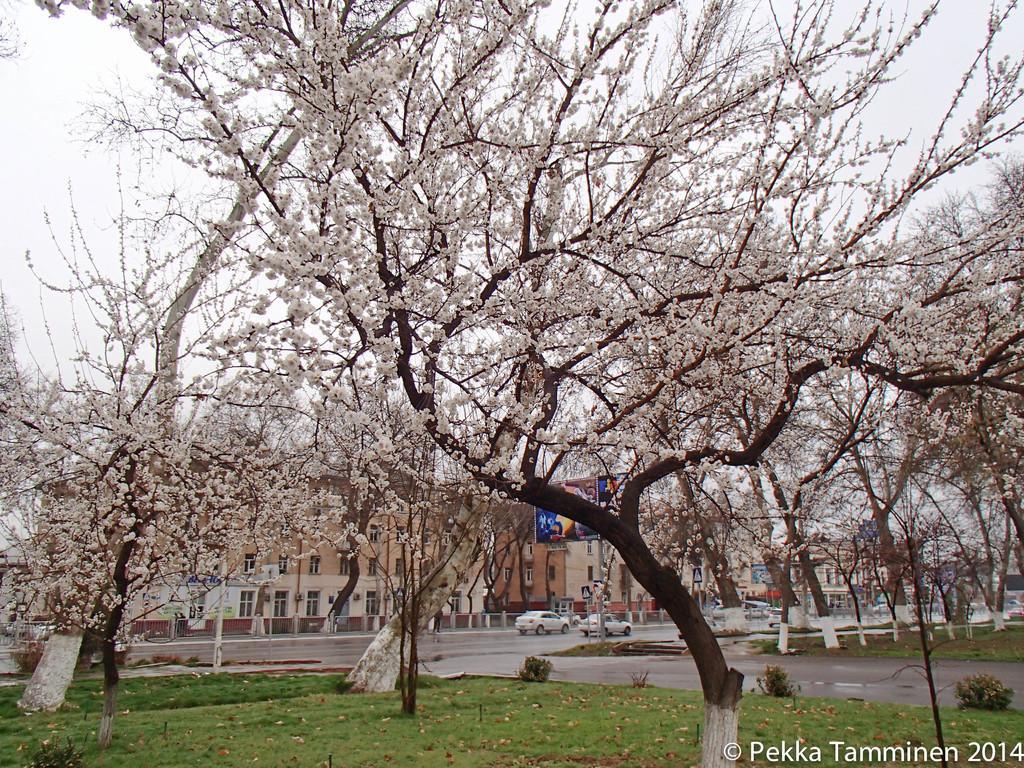Can you describe this image briefly? In the foreground of the picture I can see the trees. I can see the green grass at the bottom of the picture. In the background, I can see the buildings and there are cars on the road. 